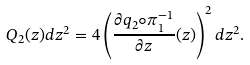Convert formula to latex. <formula><loc_0><loc_0><loc_500><loc_500>Q _ { 2 } ( z ) d z ^ { 2 } = 4 \left ( \frac { \partial q _ { 2 } \circ \pi _ { 1 } ^ { - 1 } } { \partial z } ( z ) \right ) ^ { 2 } d z ^ { 2 } .</formula> 